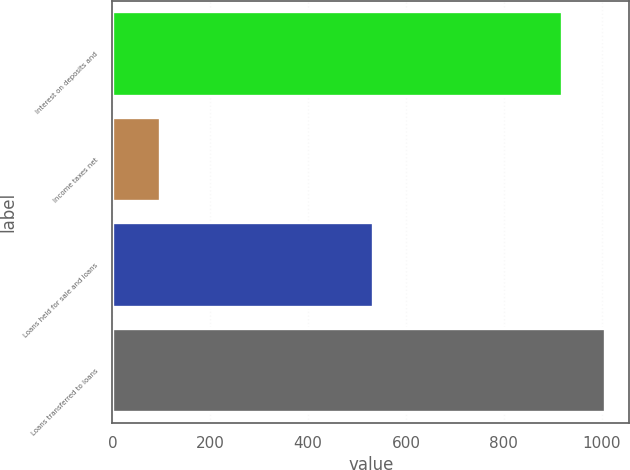Convert chart to OTSL. <chart><loc_0><loc_0><loc_500><loc_500><bar_chart><fcel>Interest on deposits and<fcel>Income taxes net<fcel>Loans held for sale and loans<fcel>Loans transferred to loans<nl><fcel>919<fcel>98<fcel>532<fcel>1006.5<nl></chart> 